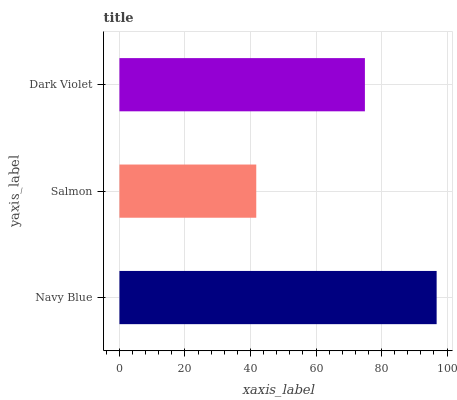Is Salmon the minimum?
Answer yes or no. Yes. Is Navy Blue the maximum?
Answer yes or no. Yes. Is Dark Violet the minimum?
Answer yes or no. No. Is Dark Violet the maximum?
Answer yes or no. No. Is Dark Violet greater than Salmon?
Answer yes or no. Yes. Is Salmon less than Dark Violet?
Answer yes or no. Yes. Is Salmon greater than Dark Violet?
Answer yes or no. No. Is Dark Violet less than Salmon?
Answer yes or no. No. Is Dark Violet the high median?
Answer yes or no. Yes. Is Dark Violet the low median?
Answer yes or no. Yes. Is Navy Blue the high median?
Answer yes or no. No. Is Navy Blue the low median?
Answer yes or no. No. 